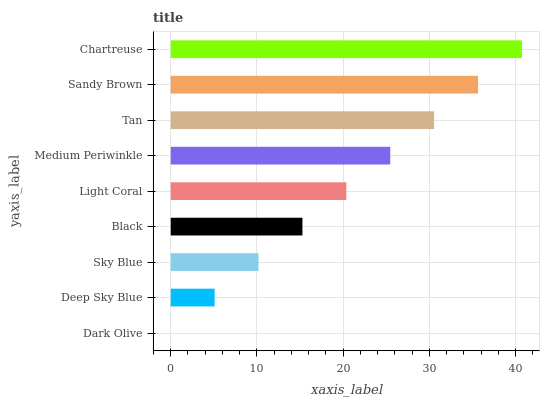Is Dark Olive the minimum?
Answer yes or no. Yes. Is Chartreuse the maximum?
Answer yes or no. Yes. Is Deep Sky Blue the minimum?
Answer yes or no. No. Is Deep Sky Blue the maximum?
Answer yes or no. No. Is Deep Sky Blue greater than Dark Olive?
Answer yes or no. Yes. Is Dark Olive less than Deep Sky Blue?
Answer yes or no. Yes. Is Dark Olive greater than Deep Sky Blue?
Answer yes or no. No. Is Deep Sky Blue less than Dark Olive?
Answer yes or no. No. Is Light Coral the high median?
Answer yes or no. Yes. Is Light Coral the low median?
Answer yes or no. Yes. Is Tan the high median?
Answer yes or no. No. Is Tan the low median?
Answer yes or no. No. 